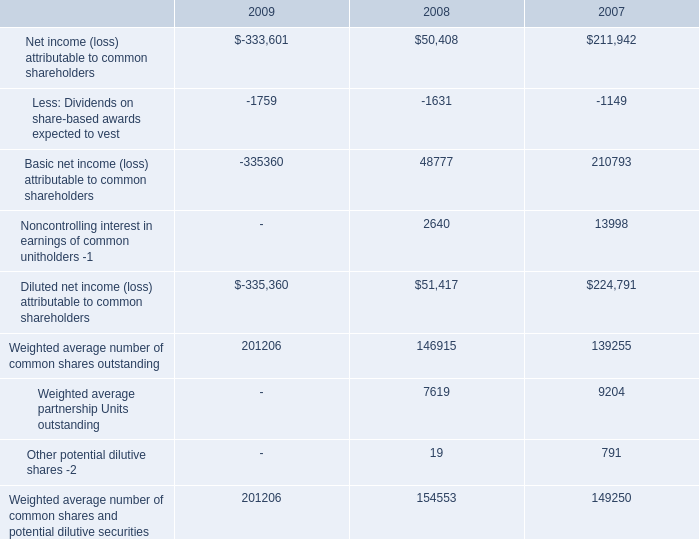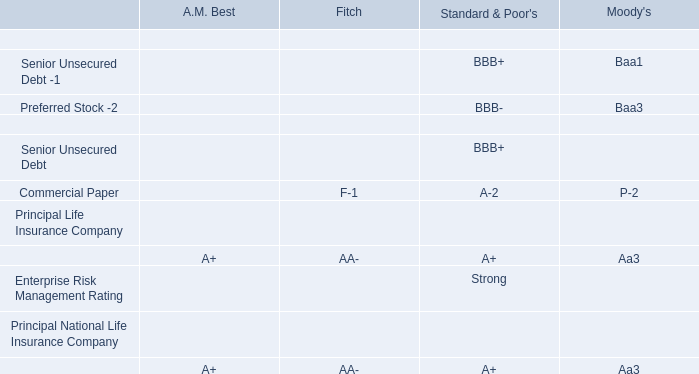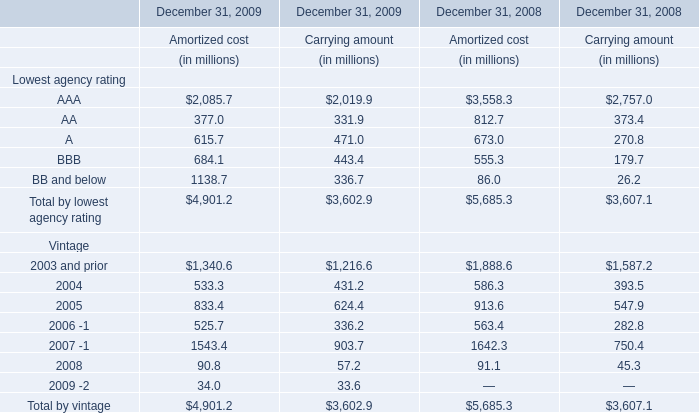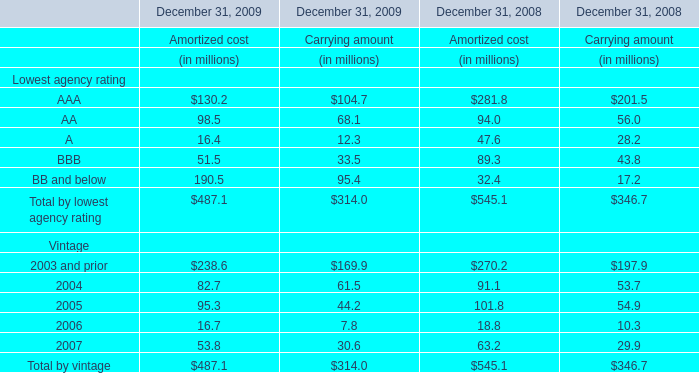What is the average amount of Weighted average number of common shares outstanding of 2007, and AAA of December 31, 2009 Amortized cost ? 
Computations: ((139255.0 + 2085.7) / 2)
Answer: 70670.35. 